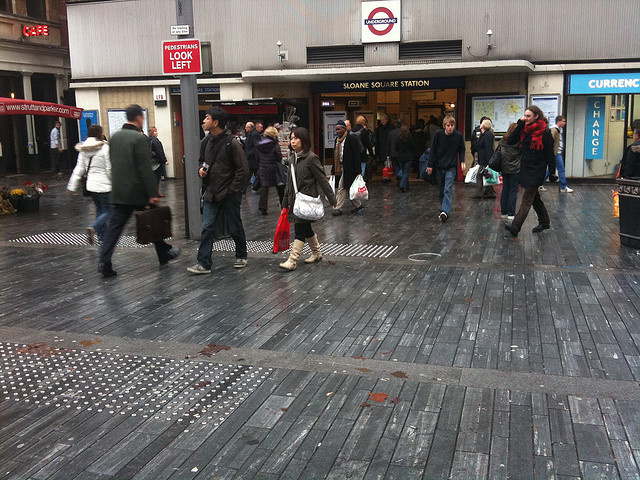Please transcribe the text information in this image. SLOAME SOUARE STATION LOOK LEFT CAFE CURRENC CHANGE 